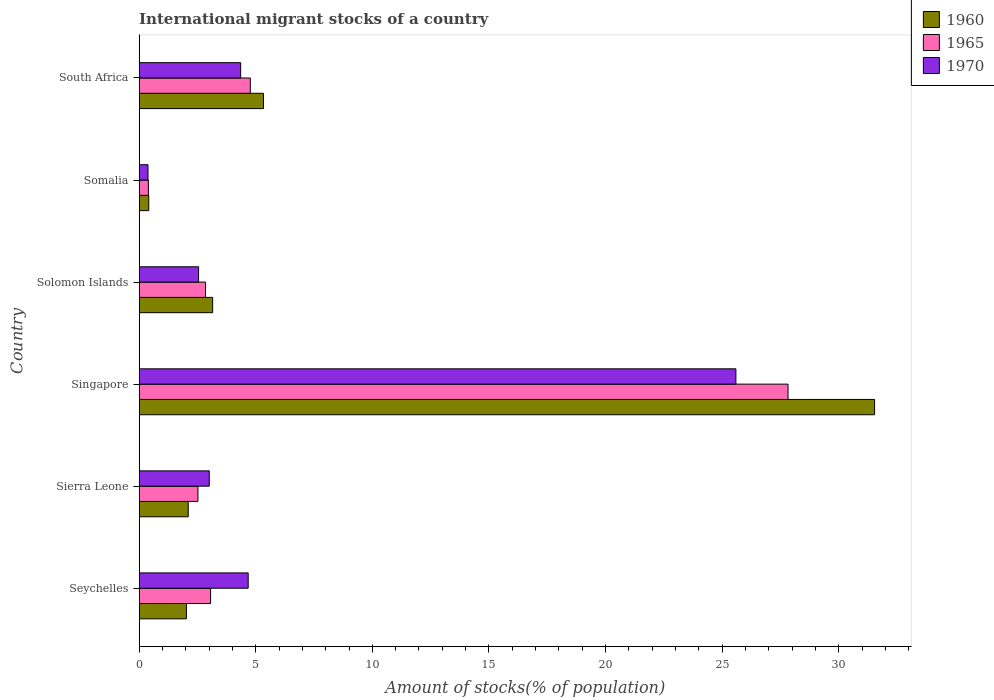How many different coloured bars are there?
Ensure brevity in your answer.  3. Are the number of bars on each tick of the Y-axis equal?
Provide a succinct answer. Yes. How many bars are there on the 5th tick from the top?
Ensure brevity in your answer.  3. How many bars are there on the 2nd tick from the bottom?
Provide a short and direct response. 3. What is the label of the 3rd group of bars from the top?
Offer a very short reply. Solomon Islands. In how many cases, is the number of bars for a given country not equal to the number of legend labels?
Keep it short and to the point. 0. What is the amount of stocks in in 1970 in Seychelles?
Provide a short and direct response. 4.68. Across all countries, what is the maximum amount of stocks in in 1970?
Provide a succinct answer. 25.59. Across all countries, what is the minimum amount of stocks in in 1970?
Make the answer very short. 0.38. In which country was the amount of stocks in in 1965 maximum?
Ensure brevity in your answer.  Singapore. In which country was the amount of stocks in in 1960 minimum?
Give a very brief answer. Somalia. What is the total amount of stocks in in 1965 in the graph?
Offer a terse response. 41.42. What is the difference between the amount of stocks in in 1970 in Seychelles and that in Sierra Leone?
Give a very brief answer. 1.67. What is the difference between the amount of stocks in in 1960 in Singapore and the amount of stocks in in 1965 in Somalia?
Your response must be concise. 31.14. What is the average amount of stocks in in 1965 per country?
Your answer should be compact. 6.9. What is the difference between the amount of stocks in in 1960 and amount of stocks in in 1970 in Seychelles?
Provide a short and direct response. -2.65. What is the ratio of the amount of stocks in in 1970 in Sierra Leone to that in Singapore?
Keep it short and to the point. 0.12. What is the difference between the highest and the second highest amount of stocks in in 1970?
Make the answer very short. 20.92. What is the difference between the highest and the lowest amount of stocks in in 1970?
Your answer should be compact. 25.21. Is the sum of the amount of stocks in in 1960 in Seychelles and South Africa greater than the maximum amount of stocks in in 1970 across all countries?
Offer a very short reply. No. What does the 1st bar from the top in Singapore represents?
Ensure brevity in your answer.  1970. Is it the case that in every country, the sum of the amount of stocks in in 1970 and amount of stocks in in 1965 is greater than the amount of stocks in in 1960?
Keep it short and to the point. Yes. Are all the bars in the graph horizontal?
Make the answer very short. Yes. Does the graph contain any zero values?
Your answer should be very brief. No. Where does the legend appear in the graph?
Make the answer very short. Top right. What is the title of the graph?
Your answer should be very brief. International migrant stocks of a country. Does "1984" appear as one of the legend labels in the graph?
Offer a terse response. No. What is the label or title of the X-axis?
Make the answer very short. Amount of stocks(% of population). What is the Amount of stocks(% of population) in 1960 in Seychelles?
Your answer should be compact. 2.03. What is the Amount of stocks(% of population) in 1965 in Seychelles?
Keep it short and to the point. 3.06. What is the Amount of stocks(% of population) in 1970 in Seychelles?
Provide a short and direct response. 4.68. What is the Amount of stocks(% of population) of 1960 in Sierra Leone?
Give a very brief answer. 2.1. What is the Amount of stocks(% of population) in 1965 in Sierra Leone?
Make the answer very short. 2.52. What is the Amount of stocks(% of population) of 1970 in Sierra Leone?
Your response must be concise. 3.01. What is the Amount of stocks(% of population) in 1960 in Singapore?
Offer a very short reply. 31.54. What is the Amount of stocks(% of population) of 1965 in Singapore?
Ensure brevity in your answer.  27.83. What is the Amount of stocks(% of population) of 1970 in Singapore?
Your answer should be very brief. 25.59. What is the Amount of stocks(% of population) in 1960 in Solomon Islands?
Keep it short and to the point. 3.15. What is the Amount of stocks(% of population) in 1965 in Solomon Islands?
Your answer should be very brief. 2.85. What is the Amount of stocks(% of population) in 1970 in Solomon Islands?
Keep it short and to the point. 2.55. What is the Amount of stocks(% of population) in 1960 in Somalia?
Offer a very short reply. 0.41. What is the Amount of stocks(% of population) in 1965 in Somalia?
Make the answer very short. 0.4. What is the Amount of stocks(% of population) of 1970 in Somalia?
Give a very brief answer. 0.38. What is the Amount of stocks(% of population) in 1960 in South Africa?
Provide a succinct answer. 5.33. What is the Amount of stocks(% of population) in 1965 in South Africa?
Offer a very short reply. 4.77. What is the Amount of stocks(% of population) of 1970 in South Africa?
Offer a very short reply. 4.35. Across all countries, what is the maximum Amount of stocks(% of population) in 1960?
Make the answer very short. 31.54. Across all countries, what is the maximum Amount of stocks(% of population) of 1965?
Give a very brief answer. 27.83. Across all countries, what is the maximum Amount of stocks(% of population) in 1970?
Make the answer very short. 25.59. Across all countries, what is the minimum Amount of stocks(% of population) of 1960?
Offer a very short reply. 0.41. Across all countries, what is the minimum Amount of stocks(% of population) of 1965?
Ensure brevity in your answer.  0.4. Across all countries, what is the minimum Amount of stocks(% of population) of 1970?
Your answer should be compact. 0.38. What is the total Amount of stocks(% of population) in 1960 in the graph?
Keep it short and to the point. 44.57. What is the total Amount of stocks(% of population) of 1965 in the graph?
Make the answer very short. 41.42. What is the total Amount of stocks(% of population) in 1970 in the graph?
Provide a succinct answer. 40.55. What is the difference between the Amount of stocks(% of population) in 1960 in Seychelles and that in Sierra Leone?
Give a very brief answer. -0.08. What is the difference between the Amount of stocks(% of population) of 1965 in Seychelles and that in Sierra Leone?
Offer a terse response. 0.54. What is the difference between the Amount of stocks(% of population) in 1970 in Seychelles and that in Sierra Leone?
Your response must be concise. 1.67. What is the difference between the Amount of stocks(% of population) in 1960 in Seychelles and that in Singapore?
Offer a terse response. -29.51. What is the difference between the Amount of stocks(% of population) in 1965 in Seychelles and that in Singapore?
Give a very brief answer. -24.76. What is the difference between the Amount of stocks(% of population) of 1970 in Seychelles and that in Singapore?
Your answer should be very brief. -20.91. What is the difference between the Amount of stocks(% of population) in 1960 in Seychelles and that in Solomon Islands?
Offer a very short reply. -1.13. What is the difference between the Amount of stocks(% of population) of 1965 in Seychelles and that in Solomon Islands?
Ensure brevity in your answer.  0.22. What is the difference between the Amount of stocks(% of population) of 1970 in Seychelles and that in Solomon Islands?
Provide a succinct answer. 2.13. What is the difference between the Amount of stocks(% of population) in 1960 in Seychelles and that in Somalia?
Offer a terse response. 1.61. What is the difference between the Amount of stocks(% of population) of 1965 in Seychelles and that in Somalia?
Keep it short and to the point. 2.67. What is the difference between the Amount of stocks(% of population) in 1970 in Seychelles and that in Somalia?
Make the answer very short. 4.3. What is the difference between the Amount of stocks(% of population) in 1960 in Seychelles and that in South Africa?
Give a very brief answer. -3.31. What is the difference between the Amount of stocks(% of population) in 1965 in Seychelles and that in South Africa?
Your response must be concise. -1.7. What is the difference between the Amount of stocks(% of population) of 1970 in Seychelles and that in South Africa?
Your answer should be compact. 0.32. What is the difference between the Amount of stocks(% of population) of 1960 in Sierra Leone and that in Singapore?
Keep it short and to the point. -29.43. What is the difference between the Amount of stocks(% of population) of 1965 in Sierra Leone and that in Singapore?
Provide a succinct answer. -25.31. What is the difference between the Amount of stocks(% of population) in 1970 in Sierra Leone and that in Singapore?
Offer a terse response. -22.58. What is the difference between the Amount of stocks(% of population) of 1960 in Sierra Leone and that in Solomon Islands?
Provide a succinct answer. -1.05. What is the difference between the Amount of stocks(% of population) in 1965 in Sierra Leone and that in Solomon Islands?
Give a very brief answer. -0.33. What is the difference between the Amount of stocks(% of population) of 1970 in Sierra Leone and that in Solomon Islands?
Offer a very short reply. 0.46. What is the difference between the Amount of stocks(% of population) of 1960 in Sierra Leone and that in Somalia?
Offer a terse response. 1.69. What is the difference between the Amount of stocks(% of population) in 1965 in Sierra Leone and that in Somalia?
Provide a short and direct response. 2.13. What is the difference between the Amount of stocks(% of population) in 1970 in Sierra Leone and that in Somalia?
Provide a short and direct response. 2.63. What is the difference between the Amount of stocks(% of population) in 1960 in Sierra Leone and that in South Africa?
Provide a succinct answer. -3.23. What is the difference between the Amount of stocks(% of population) of 1965 in Sierra Leone and that in South Africa?
Your answer should be very brief. -2.25. What is the difference between the Amount of stocks(% of population) in 1970 in Sierra Leone and that in South Africa?
Your response must be concise. -1.35. What is the difference between the Amount of stocks(% of population) in 1960 in Singapore and that in Solomon Islands?
Provide a short and direct response. 28.39. What is the difference between the Amount of stocks(% of population) in 1965 in Singapore and that in Solomon Islands?
Ensure brevity in your answer.  24.98. What is the difference between the Amount of stocks(% of population) in 1970 in Singapore and that in Solomon Islands?
Offer a terse response. 23.04. What is the difference between the Amount of stocks(% of population) in 1960 in Singapore and that in Somalia?
Offer a terse response. 31.13. What is the difference between the Amount of stocks(% of population) in 1965 in Singapore and that in Somalia?
Give a very brief answer. 27.43. What is the difference between the Amount of stocks(% of population) of 1970 in Singapore and that in Somalia?
Ensure brevity in your answer.  25.21. What is the difference between the Amount of stocks(% of population) in 1960 in Singapore and that in South Africa?
Provide a short and direct response. 26.21. What is the difference between the Amount of stocks(% of population) in 1965 in Singapore and that in South Africa?
Ensure brevity in your answer.  23.06. What is the difference between the Amount of stocks(% of population) in 1970 in Singapore and that in South Africa?
Provide a succinct answer. 21.24. What is the difference between the Amount of stocks(% of population) in 1960 in Solomon Islands and that in Somalia?
Offer a terse response. 2.74. What is the difference between the Amount of stocks(% of population) of 1965 in Solomon Islands and that in Somalia?
Provide a succinct answer. 2.45. What is the difference between the Amount of stocks(% of population) in 1970 in Solomon Islands and that in Somalia?
Ensure brevity in your answer.  2.17. What is the difference between the Amount of stocks(% of population) in 1960 in Solomon Islands and that in South Africa?
Your answer should be very brief. -2.18. What is the difference between the Amount of stocks(% of population) of 1965 in Solomon Islands and that in South Africa?
Provide a short and direct response. -1.92. What is the difference between the Amount of stocks(% of population) in 1970 in Solomon Islands and that in South Africa?
Make the answer very short. -1.81. What is the difference between the Amount of stocks(% of population) in 1960 in Somalia and that in South Africa?
Your response must be concise. -4.92. What is the difference between the Amount of stocks(% of population) in 1965 in Somalia and that in South Africa?
Provide a succinct answer. -4.37. What is the difference between the Amount of stocks(% of population) in 1970 in Somalia and that in South Africa?
Keep it short and to the point. -3.97. What is the difference between the Amount of stocks(% of population) in 1960 in Seychelles and the Amount of stocks(% of population) in 1965 in Sierra Leone?
Your answer should be compact. -0.49. What is the difference between the Amount of stocks(% of population) of 1960 in Seychelles and the Amount of stocks(% of population) of 1970 in Sierra Leone?
Ensure brevity in your answer.  -0.98. What is the difference between the Amount of stocks(% of population) in 1965 in Seychelles and the Amount of stocks(% of population) in 1970 in Sierra Leone?
Your response must be concise. 0.06. What is the difference between the Amount of stocks(% of population) in 1960 in Seychelles and the Amount of stocks(% of population) in 1965 in Singapore?
Your answer should be very brief. -25.8. What is the difference between the Amount of stocks(% of population) in 1960 in Seychelles and the Amount of stocks(% of population) in 1970 in Singapore?
Ensure brevity in your answer.  -23.56. What is the difference between the Amount of stocks(% of population) of 1965 in Seychelles and the Amount of stocks(% of population) of 1970 in Singapore?
Make the answer very short. -22.53. What is the difference between the Amount of stocks(% of population) in 1960 in Seychelles and the Amount of stocks(% of population) in 1965 in Solomon Islands?
Ensure brevity in your answer.  -0.82. What is the difference between the Amount of stocks(% of population) in 1960 in Seychelles and the Amount of stocks(% of population) in 1970 in Solomon Islands?
Offer a terse response. -0.52. What is the difference between the Amount of stocks(% of population) of 1965 in Seychelles and the Amount of stocks(% of population) of 1970 in Solomon Islands?
Make the answer very short. 0.52. What is the difference between the Amount of stocks(% of population) in 1960 in Seychelles and the Amount of stocks(% of population) in 1965 in Somalia?
Your response must be concise. 1.63. What is the difference between the Amount of stocks(% of population) in 1960 in Seychelles and the Amount of stocks(% of population) in 1970 in Somalia?
Your response must be concise. 1.65. What is the difference between the Amount of stocks(% of population) in 1965 in Seychelles and the Amount of stocks(% of population) in 1970 in Somalia?
Offer a terse response. 2.68. What is the difference between the Amount of stocks(% of population) in 1960 in Seychelles and the Amount of stocks(% of population) in 1965 in South Africa?
Provide a short and direct response. -2.74. What is the difference between the Amount of stocks(% of population) in 1960 in Seychelles and the Amount of stocks(% of population) in 1970 in South Africa?
Your answer should be very brief. -2.33. What is the difference between the Amount of stocks(% of population) in 1965 in Seychelles and the Amount of stocks(% of population) in 1970 in South Africa?
Keep it short and to the point. -1.29. What is the difference between the Amount of stocks(% of population) in 1960 in Sierra Leone and the Amount of stocks(% of population) in 1965 in Singapore?
Give a very brief answer. -25.72. What is the difference between the Amount of stocks(% of population) of 1960 in Sierra Leone and the Amount of stocks(% of population) of 1970 in Singapore?
Provide a succinct answer. -23.49. What is the difference between the Amount of stocks(% of population) of 1965 in Sierra Leone and the Amount of stocks(% of population) of 1970 in Singapore?
Ensure brevity in your answer.  -23.07. What is the difference between the Amount of stocks(% of population) of 1960 in Sierra Leone and the Amount of stocks(% of population) of 1965 in Solomon Islands?
Provide a succinct answer. -0.74. What is the difference between the Amount of stocks(% of population) of 1960 in Sierra Leone and the Amount of stocks(% of population) of 1970 in Solomon Islands?
Make the answer very short. -0.44. What is the difference between the Amount of stocks(% of population) of 1965 in Sierra Leone and the Amount of stocks(% of population) of 1970 in Solomon Islands?
Offer a terse response. -0.03. What is the difference between the Amount of stocks(% of population) of 1960 in Sierra Leone and the Amount of stocks(% of population) of 1965 in Somalia?
Your response must be concise. 1.71. What is the difference between the Amount of stocks(% of population) in 1960 in Sierra Leone and the Amount of stocks(% of population) in 1970 in Somalia?
Make the answer very short. 1.73. What is the difference between the Amount of stocks(% of population) of 1965 in Sierra Leone and the Amount of stocks(% of population) of 1970 in Somalia?
Provide a succinct answer. 2.14. What is the difference between the Amount of stocks(% of population) in 1960 in Sierra Leone and the Amount of stocks(% of population) in 1965 in South Africa?
Your answer should be very brief. -2.66. What is the difference between the Amount of stocks(% of population) of 1960 in Sierra Leone and the Amount of stocks(% of population) of 1970 in South Africa?
Ensure brevity in your answer.  -2.25. What is the difference between the Amount of stocks(% of population) of 1965 in Sierra Leone and the Amount of stocks(% of population) of 1970 in South Africa?
Provide a succinct answer. -1.83. What is the difference between the Amount of stocks(% of population) of 1960 in Singapore and the Amount of stocks(% of population) of 1965 in Solomon Islands?
Your answer should be compact. 28.69. What is the difference between the Amount of stocks(% of population) in 1960 in Singapore and the Amount of stocks(% of population) in 1970 in Solomon Islands?
Your answer should be compact. 28.99. What is the difference between the Amount of stocks(% of population) in 1965 in Singapore and the Amount of stocks(% of population) in 1970 in Solomon Islands?
Your response must be concise. 25.28. What is the difference between the Amount of stocks(% of population) of 1960 in Singapore and the Amount of stocks(% of population) of 1965 in Somalia?
Your answer should be compact. 31.14. What is the difference between the Amount of stocks(% of population) in 1960 in Singapore and the Amount of stocks(% of population) in 1970 in Somalia?
Your answer should be very brief. 31.16. What is the difference between the Amount of stocks(% of population) of 1965 in Singapore and the Amount of stocks(% of population) of 1970 in Somalia?
Offer a terse response. 27.45. What is the difference between the Amount of stocks(% of population) in 1960 in Singapore and the Amount of stocks(% of population) in 1965 in South Africa?
Your answer should be very brief. 26.77. What is the difference between the Amount of stocks(% of population) of 1960 in Singapore and the Amount of stocks(% of population) of 1970 in South Africa?
Provide a short and direct response. 27.18. What is the difference between the Amount of stocks(% of population) of 1965 in Singapore and the Amount of stocks(% of population) of 1970 in South Africa?
Your answer should be compact. 23.47. What is the difference between the Amount of stocks(% of population) in 1960 in Solomon Islands and the Amount of stocks(% of population) in 1965 in Somalia?
Your answer should be compact. 2.76. What is the difference between the Amount of stocks(% of population) in 1960 in Solomon Islands and the Amount of stocks(% of population) in 1970 in Somalia?
Offer a very short reply. 2.77. What is the difference between the Amount of stocks(% of population) in 1965 in Solomon Islands and the Amount of stocks(% of population) in 1970 in Somalia?
Give a very brief answer. 2.47. What is the difference between the Amount of stocks(% of population) of 1960 in Solomon Islands and the Amount of stocks(% of population) of 1965 in South Africa?
Make the answer very short. -1.61. What is the difference between the Amount of stocks(% of population) of 1960 in Solomon Islands and the Amount of stocks(% of population) of 1970 in South Africa?
Give a very brief answer. -1.2. What is the difference between the Amount of stocks(% of population) in 1965 in Solomon Islands and the Amount of stocks(% of population) in 1970 in South Africa?
Make the answer very short. -1.51. What is the difference between the Amount of stocks(% of population) in 1960 in Somalia and the Amount of stocks(% of population) in 1965 in South Africa?
Give a very brief answer. -4.35. What is the difference between the Amount of stocks(% of population) of 1960 in Somalia and the Amount of stocks(% of population) of 1970 in South Africa?
Your answer should be very brief. -3.94. What is the difference between the Amount of stocks(% of population) in 1965 in Somalia and the Amount of stocks(% of population) in 1970 in South Africa?
Offer a terse response. -3.96. What is the average Amount of stocks(% of population) of 1960 per country?
Make the answer very short. 7.43. What is the average Amount of stocks(% of population) in 1965 per country?
Keep it short and to the point. 6.9. What is the average Amount of stocks(% of population) of 1970 per country?
Offer a terse response. 6.76. What is the difference between the Amount of stocks(% of population) in 1960 and Amount of stocks(% of population) in 1965 in Seychelles?
Provide a short and direct response. -1.04. What is the difference between the Amount of stocks(% of population) of 1960 and Amount of stocks(% of population) of 1970 in Seychelles?
Your answer should be compact. -2.65. What is the difference between the Amount of stocks(% of population) of 1965 and Amount of stocks(% of population) of 1970 in Seychelles?
Provide a short and direct response. -1.61. What is the difference between the Amount of stocks(% of population) in 1960 and Amount of stocks(% of population) in 1965 in Sierra Leone?
Provide a short and direct response. -0.42. What is the difference between the Amount of stocks(% of population) of 1960 and Amount of stocks(% of population) of 1970 in Sierra Leone?
Ensure brevity in your answer.  -0.9. What is the difference between the Amount of stocks(% of population) in 1965 and Amount of stocks(% of population) in 1970 in Sierra Leone?
Your response must be concise. -0.49. What is the difference between the Amount of stocks(% of population) of 1960 and Amount of stocks(% of population) of 1965 in Singapore?
Offer a terse response. 3.71. What is the difference between the Amount of stocks(% of population) in 1960 and Amount of stocks(% of population) in 1970 in Singapore?
Your response must be concise. 5.95. What is the difference between the Amount of stocks(% of population) of 1965 and Amount of stocks(% of population) of 1970 in Singapore?
Give a very brief answer. 2.24. What is the difference between the Amount of stocks(% of population) of 1960 and Amount of stocks(% of population) of 1965 in Solomon Islands?
Keep it short and to the point. 0.31. What is the difference between the Amount of stocks(% of population) in 1960 and Amount of stocks(% of population) in 1970 in Solomon Islands?
Your answer should be compact. 0.6. What is the difference between the Amount of stocks(% of population) in 1965 and Amount of stocks(% of population) in 1970 in Solomon Islands?
Your response must be concise. 0.3. What is the difference between the Amount of stocks(% of population) in 1960 and Amount of stocks(% of population) in 1965 in Somalia?
Give a very brief answer. 0.02. What is the difference between the Amount of stocks(% of population) of 1960 and Amount of stocks(% of population) of 1970 in Somalia?
Provide a short and direct response. 0.03. What is the difference between the Amount of stocks(% of population) in 1965 and Amount of stocks(% of population) in 1970 in Somalia?
Your answer should be compact. 0.02. What is the difference between the Amount of stocks(% of population) of 1960 and Amount of stocks(% of population) of 1965 in South Africa?
Ensure brevity in your answer.  0.57. What is the difference between the Amount of stocks(% of population) in 1960 and Amount of stocks(% of population) in 1970 in South Africa?
Offer a terse response. 0.98. What is the difference between the Amount of stocks(% of population) in 1965 and Amount of stocks(% of population) in 1970 in South Africa?
Ensure brevity in your answer.  0.41. What is the ratio of the Amount of stocks(% of population) in 1960 in Seychelles to that in Sierra Leone?
Give a very brief answer. 0.96. What is the ratio of the Amount of stocks(% of population) of 1965 in Seychelles to that in Sierra Leone?
Provide a succinct answer. 1.22. What is the ratio of the Amount of stocks(% of population) of 1970 in Seychelles to that in Sierra Leone?
Your answer should be very brief. 1.56. What is the ratio of the Amount of stocks(% of population) in 1960 in Seychelles to that in Singapore?
Your answer should be compact. 0.06. What is the ratio of the Amount of stocks(% of population) of 1965 in Seychelles to that in Singapore?
Provide a short and direct response. 0.11. What is the ratio of the Amount of stocks(% of population) in 1970 in Seychelles to that in Singapore?
Provide a short and direct response. 0.18. What is the ratio of the Amount of stocks(% of population) in 1960 in Seychelles to that in Solomon Islands?
Keep it short and to the point. 0.64. What is the ratio of the Amount of stocks(% of population) in 1965 in Seychelles to that in Solomon Islands?
Your answer should be very brief. 1.08. What is the ratio of the Amount of stocks(% of population) of 1970 in Seychelles to that in Solomon Islands?
Your answer should be very brief. 1.83. What is the ratio of the Amount of stocks(% of population) in 1960 in Seychelles to that in Somalia?
Ensure brevity in your answer.  4.92. What is the ratio of the Amount of stocks(% of population) in 1965 in Seychelles to that in Somalia?
Your response must be concise. 7.75. What is the ratio of the Amount of stocks(% of population) of 1970 in Seychelles to that in Somalia?
Your answer should be very brief. 12.35. What is the ratio of the Amount of stocks(% of population) of 1960 in Seychelles to that in South Africa?
Make the answer very short. 0.38. What is the ratio of the Amount of stocks(% of population) in 1965 in Seychelles to that in South Africa?
Provide a succinct answer. 0.64. What is the ratio of the Amount of stocks(% of population) in 1970 in Seychelles to that in South Africa?
Offer a very short reply. 1.07. What is the ratio of the Amount of stocks(% of population) in 1960 in Sierra Leone to that in Singapore?
Your response must be concise. 0.07. What is the ratio of the Amount of stocks(% of population) in 1965 in Sierra Leone to that in Singapore?
Provide a short and direct response. 0.09. What is the ratio of the Amount of stocks(% of population) of 1970 in Sierra Leone to that in Singapore?
Your answer should be compact. 0.12. What is the ratio of the Amount of stocks(% of population) of 1960 in Sierra Leone to that in Solomon Islands?
Your answer should be very brief. 0.67. What is the ratio of the Amount of stocks(% of population) of 1965 in Sierra Leone to that in Solomon Islands?
Keep it short and to the point. 0.89. What is the ratio of the Amount of stocks(% of population) of 1970 in Sierra Leone to that in Solomon Islands?
Ensure brevity in your answer.  1.18. What is the ratio of the Amount of stocks(% of population) in 1960 in Sierra Leone to that in Somalia?
Offer a very short reply. 5.11. What is the ratio of the Amount of stocks(% of population) in 1965 in Sierra Leone to that in Somalia?
Offer a terse response. 6.38. What is the ratio of the Amount of stocks(% of population) of 1970 in Sierra Leone to that in Somalia?
Your answer should be compact. 7.94. What is the ratio of the Amount of stocks(% of population) of 1960 in Sierra Leone to that in South Africa?
Your response must be concise. 0.39. What is the ratio of the Amount of stocks(% of population) in 1965 in Sierra Leone to that in South Africa?
Provide a short and direct response. 0.53. What is the ratio of the Amount of stocks(% of population) in 1970 in Sierra Leone to that in South Africa?
Your answer should be very brief. 0.69. What is the ratio of the Amount of stocks(% of population) of 1960 in Singapore to that in Solomon Islands?
Provide a succinct answer. 10.01. What is the ratio of the Amount of stocks(% of population) in 1965 in Singapore to that in Solomon Islands?
Your response must be concise. 9.78. What is the ratio of the Amount of stocks(% of population) of 1970 in Singapore to that in Solomon Islands?
Your answer should be very brief. 10.04. What is the ratio of the Amount of stocks(% of population) of 1960 in Singapore to that in Somalia?
Your response must be concise. 76.55. What is the ratio of the Amount of stocks(% of population) of 1965 in Singapore to that in Somalia?
Ensure brevity in your answer.  70.38. What is the ratio of the Amount of stocks(% of population) of 1970 in Singapore to that in Somalia?
Ensure brevity in your answer.  67.61. What is the ratio of the Amount of stocks(% of population) of 1960 in Singapore to that in South Africa?
Provide a short and direct response. 5.91. What is the ratio of the Amount of stocks(% of population) of 1965 in Singapore to that in South Africa?
Your response must be concise. 5.84. What is the ratio of the Amount of stocks(% of population) of 1970 in Singapore to that in South Africa?
Offer a very short reply. 5.88. What is the ratio of the Amount of stocks(% of population) in 1960 in Solomon Islands to that in Somalia?
Make the answer very short. 7.65. What is the ratio of the Amount of stocks(% of population) in 1965 in Solomon Islands to that in Somalia?
Ensure brevity in your answer.  7.2. What is the ratio of the Amount of stocks(% of population) in 1970 in Solomon Islands to that in Somalia?
Offer a very short reply. 6.73. What is the ratio of the Amount of stocks(% of population) in 1960 in Solomon Islands to that in South Africa?
Provide a succinct answer. 0.59. What is the ratio of the Amount of stocks(% of population) of 1965 in Solomon Islands to that in South Africa?
Offer a terse response. 0.6. What is the ratio of the Amount of stocks(% of population) of 1970 in Solomon Islands to that in South Africa?
Offer a terse response. 0.59. What is the ratio of the Amount of stocks(% of population) of 1960 in Somalia to that in South Africa?
Make the answer very short. 0.08. What is the ratio of the Amount of stocks(% of population) of 1965 in Somalia to that in South Africa?
Offer a very short reply. 0.08. What is the ratio of the Amount of stocks(% of population) of 1970 in Somalia to that in South Africa?
Make the answer very short. 0.09. What is the difference between the highest and the second highest Amount of stocks(% of population) in 1960?
Offer a terse response. 26.21. What is the difference between the highest and the second highest Amount of stocks(% of population) of 1965?
Make the answer very short. 23.06. What is the difference between the highest and the second highest Amount of stocks(% of population) in 1970?
Make the answer very short. 20.91. What is the difference between the highest and the lowest Amount of stocks(% of population) of 1960?
Keep it short and to the point. 31.13. What is the difference between the highest and the lowest Amount of stocks(% of population) of 1965?
Your answer should be compact. 27.43. What is the difference between the highest and the lowest Amount of stocks(% of population) in 1970?
Ensure brevity in your answer.  25.21. 